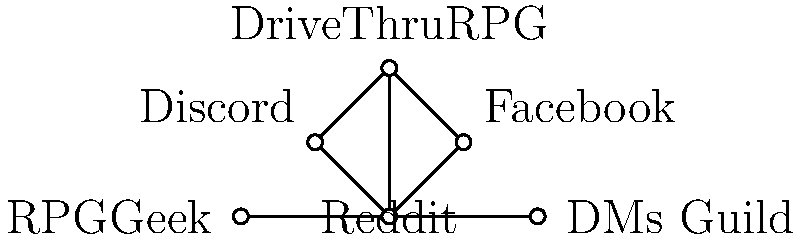Based on the network diagram showing connections between various online platforms and communities for finding Dark Sun resources, which platform appears to be the central hub with the most connections to other resources? To determine the central hub in this network diagram, we need to follow these steps:

1. Identify all the platforms represented in the diagram:
   - Reddit
   - Facebook
   - Discord
   - DriveThruRPG
   - RPGGeek
   - DMs Guild

2. Count the number of connections (edges) for each platform:
   - Reddit: 5 connections (to Facebook, Discord, DriveThruRPG, RPGGeek, and DMs Guild)
   - Facebook: 2 connections (to Reddit and DriveThruRPG)
   - Discord: 2 connections (to Reddit and DriveThruRPG)
   - DriveThruRPG: 3 connections (to Reddit, Facebook, and Discord)
   - RPGGeek: 1 connection (to Reddit)
   - DMs Guild: 1 connection (to Reddit)

3. Identify the platform with the most connections:
   Reddit has the highest number of connections (5) to other platforms in the network.

Therefore, Reddit appears to be the central hub with the most connections to other resources for finding Dark Sun materials and connecting with fellow players.
Answer: Reddit 